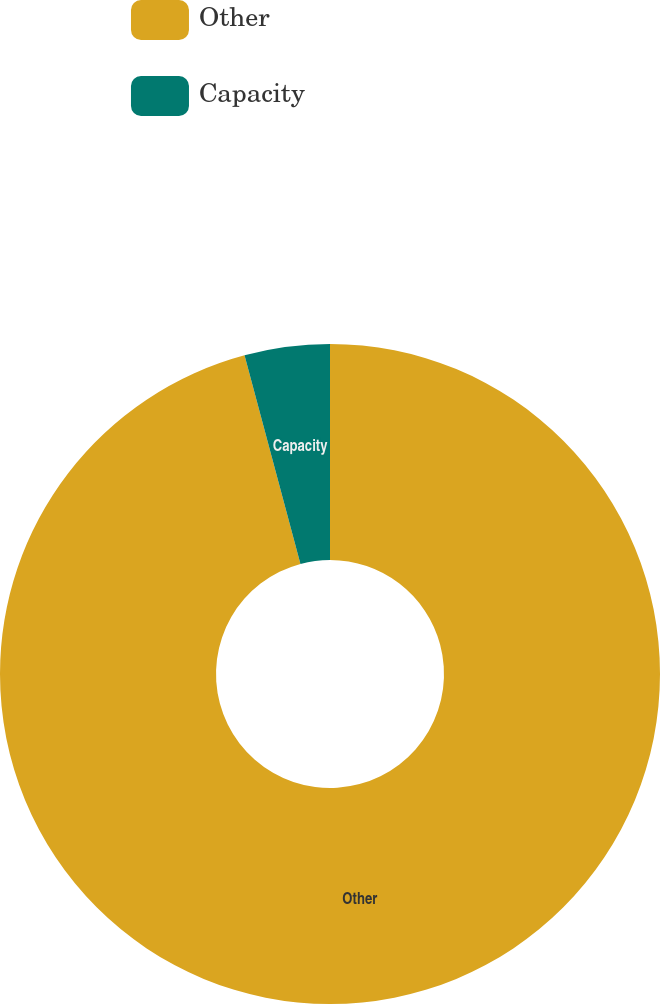Convert chart. <chart><loc_0><loc_0><loc_500><loc_500><pie_chart><fcel>Other<fcel>Capacity<nl><fcel>95.83%<fcel>4.17%<nl></chart> 